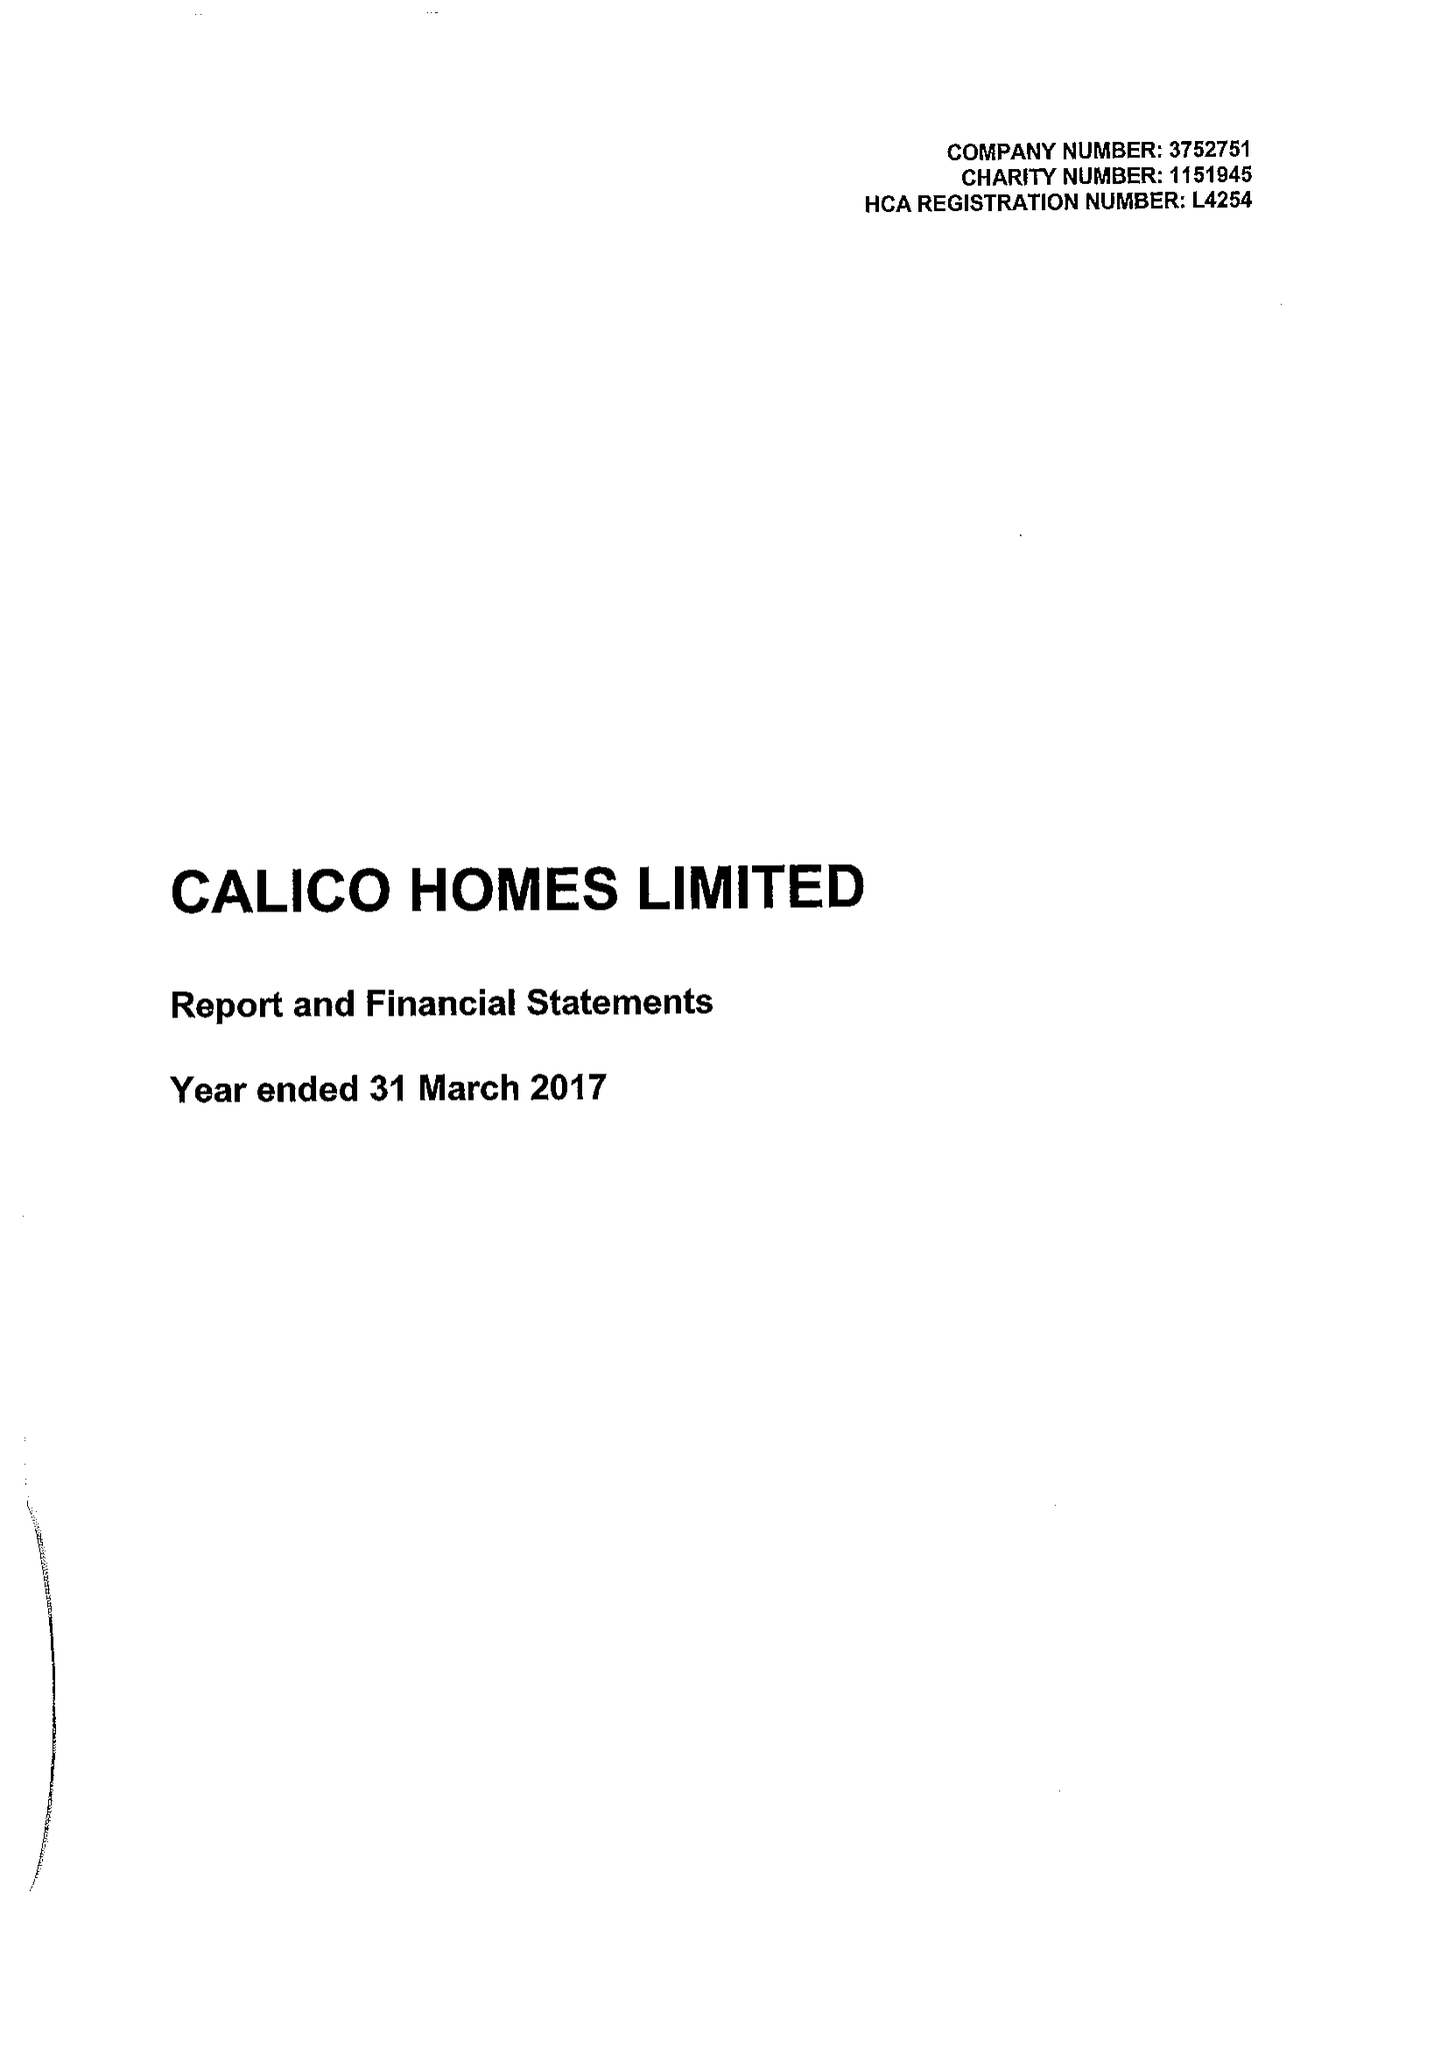What is the value for the charity_name?
Answer the question using a single word or phrase. Calico Homes Ltd. 